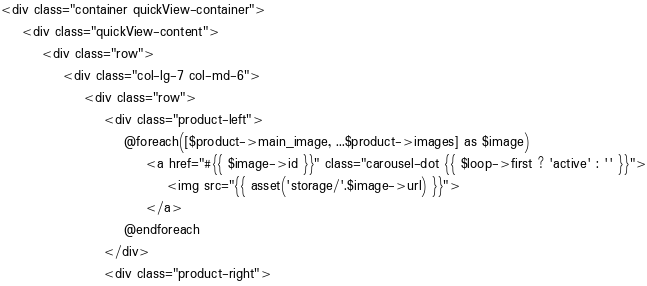Convert code to text. <code><loc_0><loc_0><loc_500><loc_500><_PHP_><div class="container quickView-container">
    <div class="quickView-content">
        <div class="row">
            <div class="col-lg-7 col-md-6">
                <div class="row">
                    <div class="product-left">
                        @foreach([$product->main_image, ...$product->images] as $image)
                            <a href="#{{ $image->id }}" class="carousel-dot {{ $loop->first ? 'active' : '' }}">
                                <img src="{{ asset('storage/'.$image->url) }}">
                            </a>
                        @endforeach
                    </div>
                    <div class="product-right"></code> 